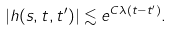Convert formula to latex. <formula><loc_0><loc_0><loc_500><loc_500>| h ( s , t , t ^ { \prime } ) | \lesssim e ^ { C \lambda ( t - t ^ { \prime } ) } .</formula> 